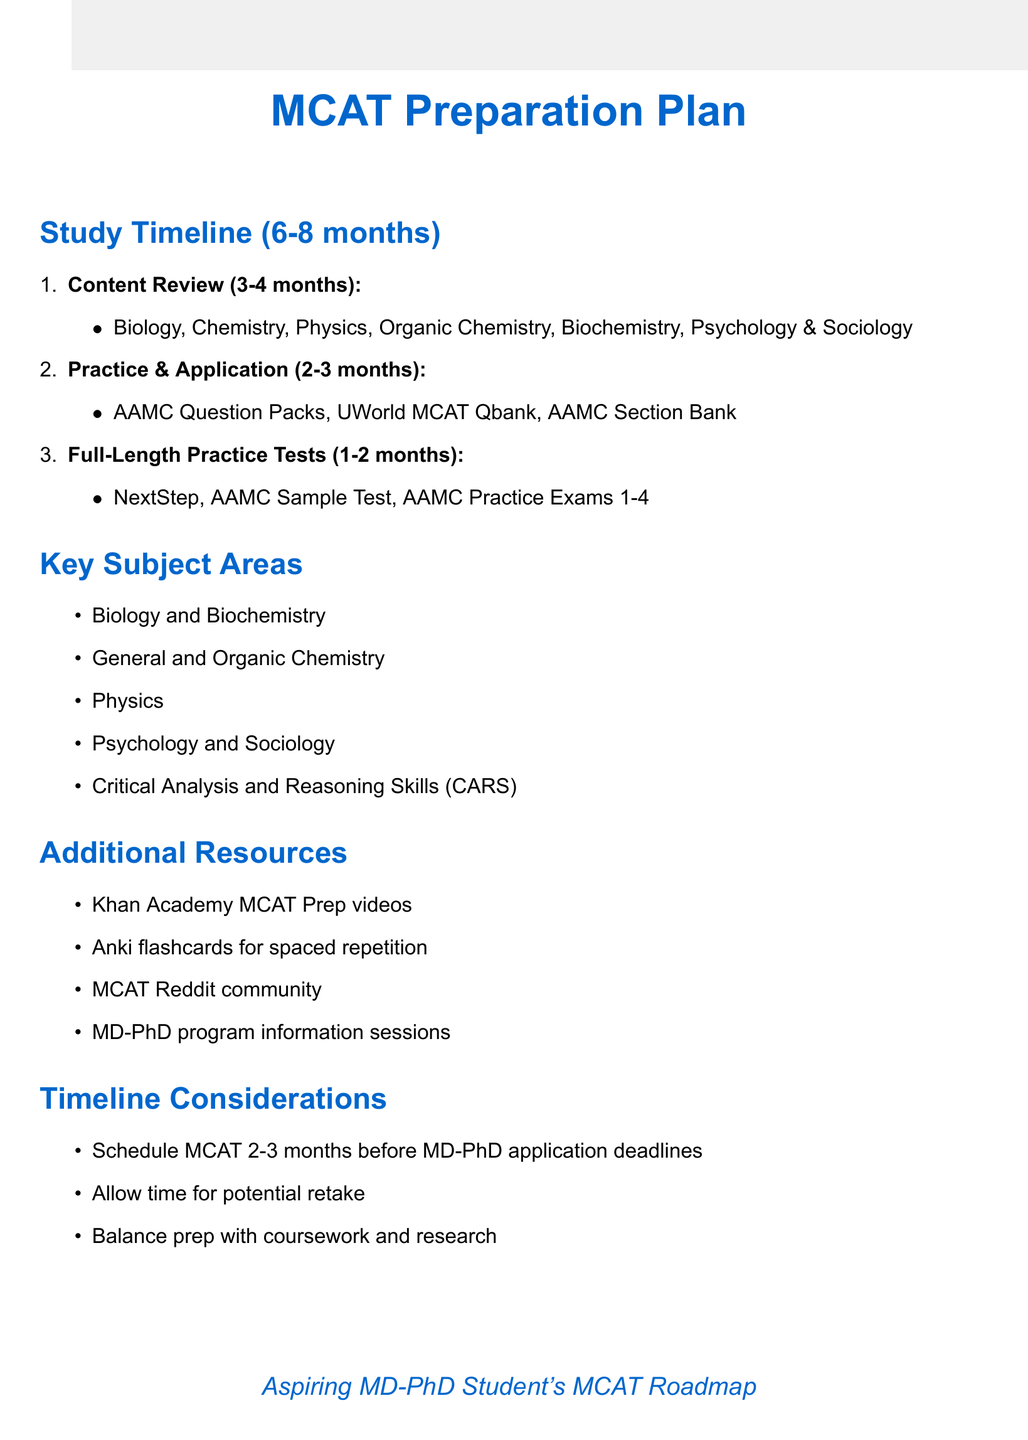What is the duration of the content review phase? The content review phase lasts for 3-4 months.
Answer: 3-4 months Which textbook is recommended for studying biology? Campbell Biology textbook is suggested for biology review.
Answer: Campbell Biology What are the two subject areas focused on in the key subject areas? Biology and Biochemistry, General and Organic Chemistry are two subjects from the key subject areas.
Answer: Biology and Biochemistry, General and Organic Chemistry How many practice exams are scheduled in the full-length practice tests phase? There are four practice exams scheduled in the full-length practice tests phase.
Answer: Four What is one of the additional resources listed for MCAT preparation? Khan Academy MCAT Prep videos is one of the additional resources mentioned.
Answer: Khan Academy MCAT Prep videos How long should you plan for MCAT preparation in total? The document suggests planning for 6-8 months of dedicated MCAT preparation.
Answer: 6-8 months What is the timeline consideration regarding the MCAT exam date? It is recommended to schedule the MCAT exam date at least 2-3 months before MD-PhD application deadlines.
Answer: 2-3 months What is the focus of the Practice and Application phase? The focus of the Practice and Application phase is to apply knowledge through various question banks and official packs.
Answer: AAMC Question Packs, UWorld MCAT Qbank, AAMC Section Bank How many months is allocated for full-length practice tests? The full-length practice tests phase is allocated 1-2 months.
Answer: 1-2 months 